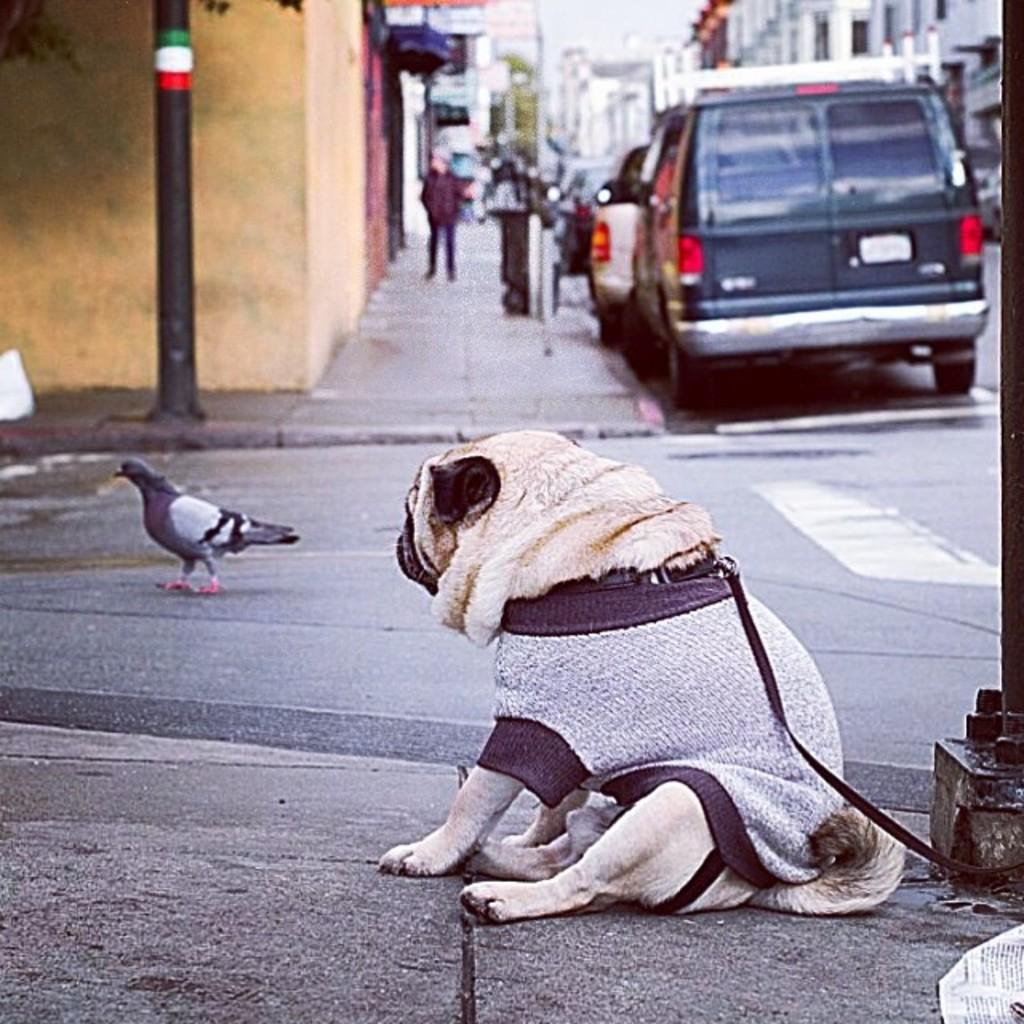Please provide a concise description of this image. In the foreground of this image, there is a dog with a belt is sitting on the pavement and also a bird on the road. In the background, there are few vehicles on the road, a person on the side path, few buildings and the sky. We can also see a pole on the left. 